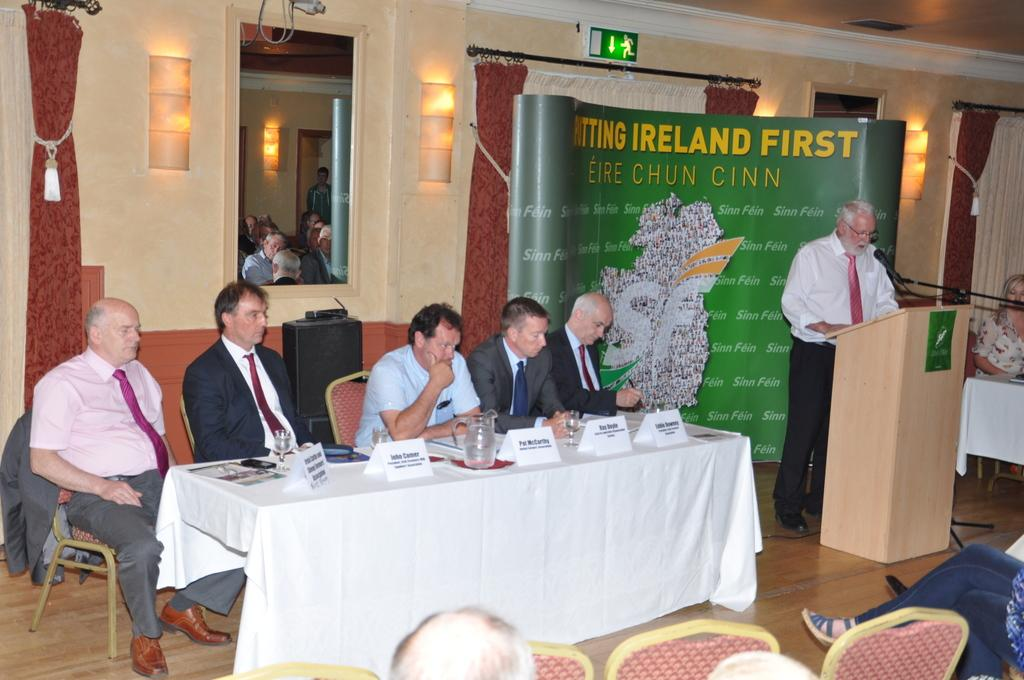How many people are sitting in the image? There are five people sitting on chairs in the image. What are the chairs positioned in front of? The chairs are in front of a desk. What can be found on the desk? There are name plates and a jug on the desk. What is the person behind the desk doing? There is a person standing behind the desk. What material is the desk made of? The desk is made of wood. What type of action can be seen on the moon in the image? There is no moon visible in the image, and therefore no action can be observed on it. Can you describe the veins in the person standing behind the desk? There is no mention of veins in the image, and we cannot see inside the person to describe their veins. 